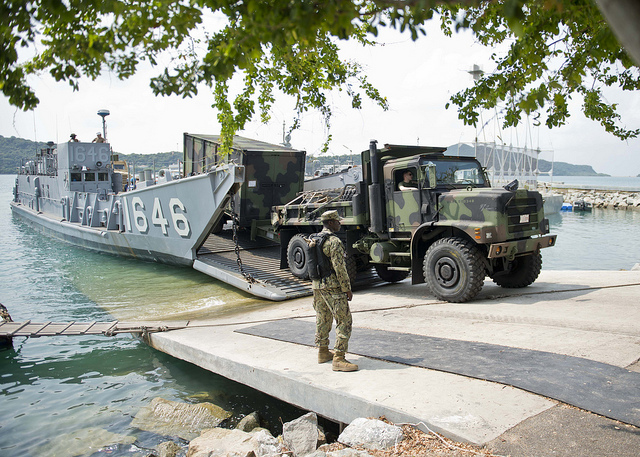How could the training from this operation affect future military responses? Training from this operation could significantly enhance future military responses by refining the skills required for rapid deployment and logistical coordination under pressured conditions. Personnel would become adept at quickly constructing functional operational bases, planning and executing large-scale equipment transport, and maintaining operational security in potentially vulnerable areas. These skills ensure the military can respond more effectively to emergencies, humanitarian crises, and unexpected strategic deployments, thereby increasing overall agility and preparedness. What might be a realistic immediate objective of this military operation? A realistic immediate objective of this military operation is likely the establishment of a temporary logistics hub to support ongoing military or humanitarian missions. This hub would facilitate the quick distribution of resources, such as vehicles and supplies, to areas in need, possibly in the aftermath of a natural disaster or to support training exercises. Ensuring the smooth unloading of equipment and maintaining communication and security are key priorities to accomplish this objective efficiently. 